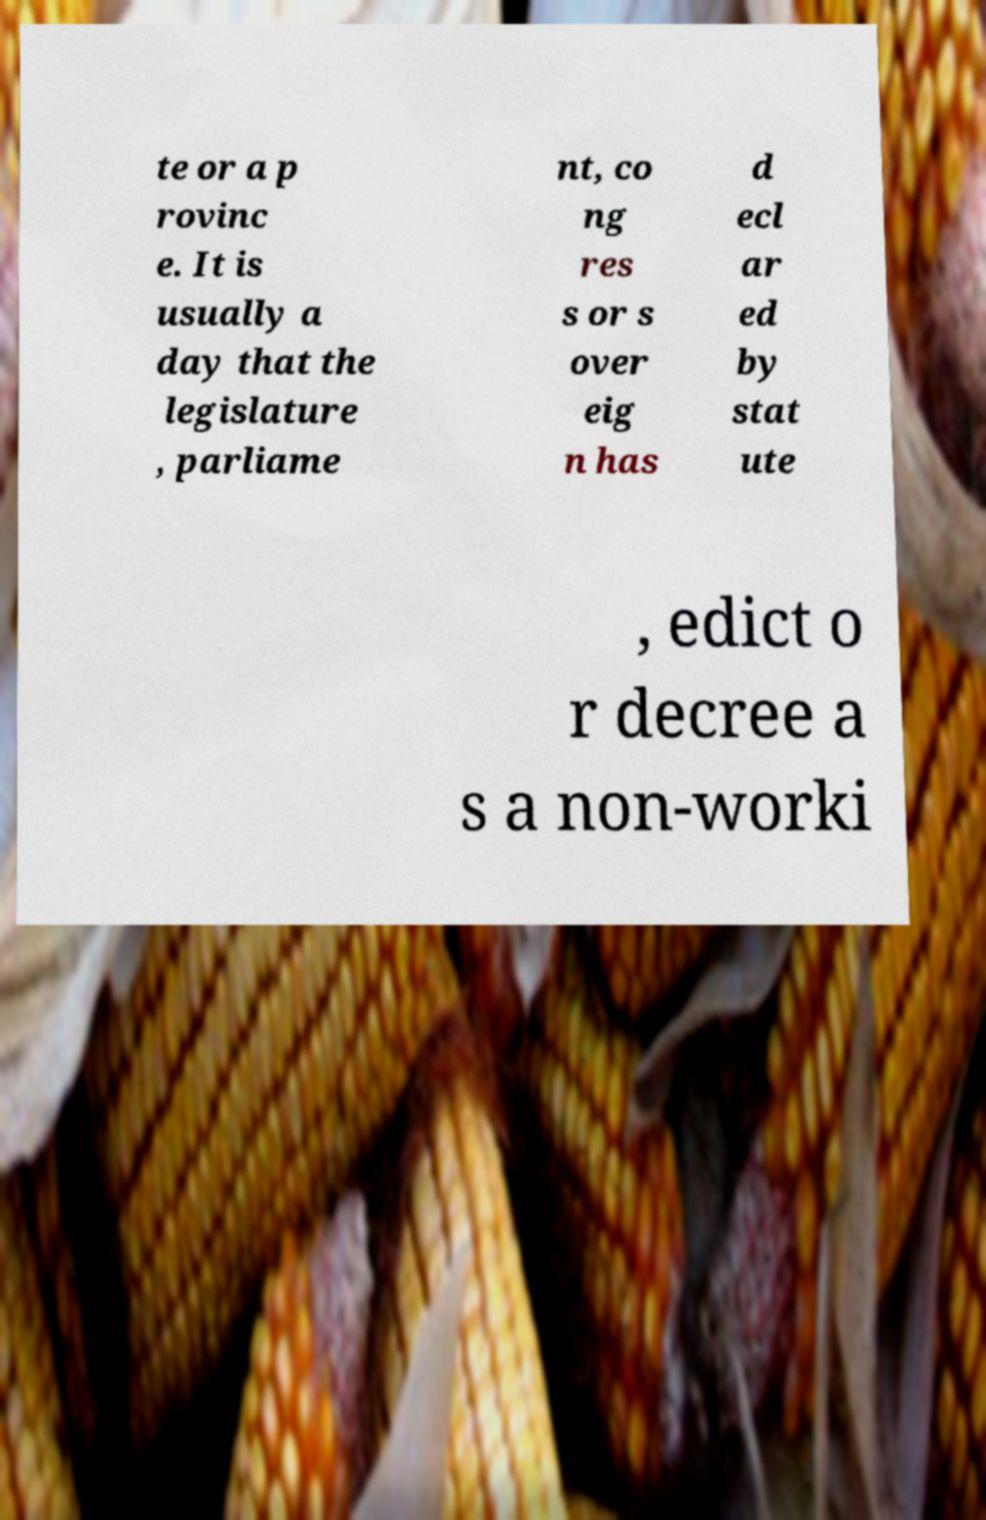Could you assist in decoding the text presented in this image and type it out clearly? te or a p rovinc e. It is usually a day that the legislature , parliame nt, co ng res s or s over eig n has d ecl ar ed by stat ute , edict o r decree a s a non-worki 